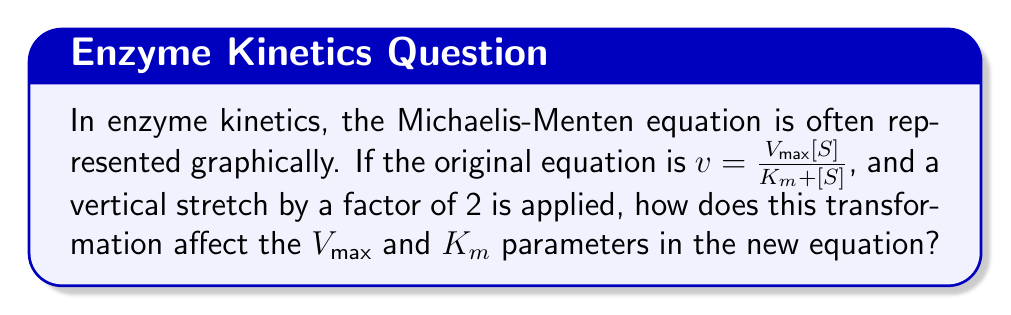Could you help me with this problem? To analyze the effect of vertical stretching on enzyme kinetics graphs, let's follow these steps:

1) The original Michaelis-Menten equation is:

   $$v = \frac{V_{max}[S]}{K_m + [S]}$$

2) A vertical stretch by a factor of 2 means multiplying the entire right side of the equation by 2:

   $$v = 2 \cdot \frac{V_{max}[S]}{K_m + [S]}$$

3) This can be rewritten as:

   $$v = \frac{2V_{max}[S]}{K_m + [S]}$$

4) Comparing this new equation to the standard form of the Michaelis-Menten equation:

   $$v = \frac{V_{max}^{new}[S]}{K_m^{new} + [S]}$$

5) We can see that:
   - $V_{max}^{new} = 2V_{max}$
   - $K_m^{new} = K_m$

6) Therefore, the vertical stretch has doubled the $V_{max}$ parameter, while leaving the $K_m$ parameter unchanged.

This transformation would result in a graph that reaches twice the maximum velocity (at high substrate concentrations) compared to the original, but the substrate concentration at half-maximum velocity ($K_m$) remains the same.
Answer: $V_{max}$ doubles, $K_m$ remains unchanged. 